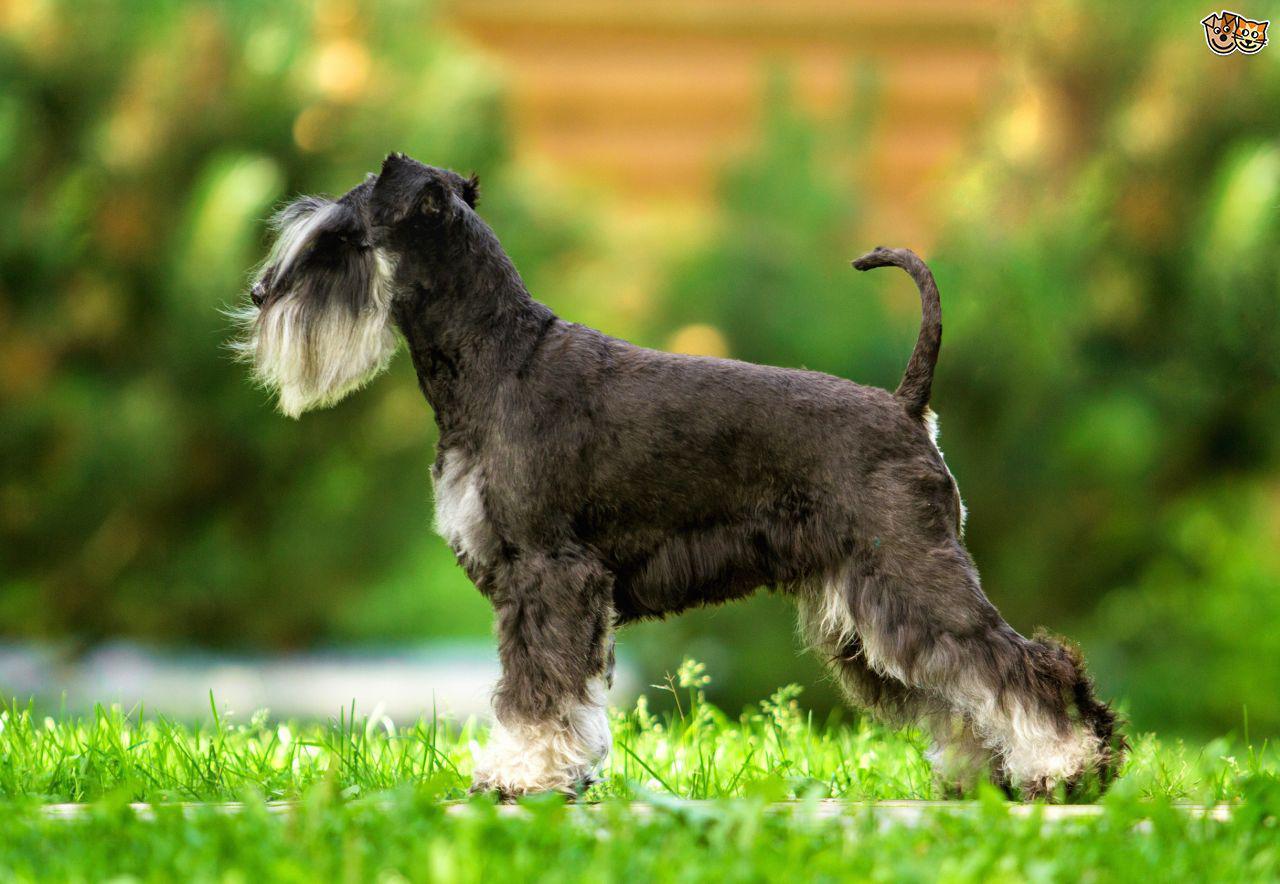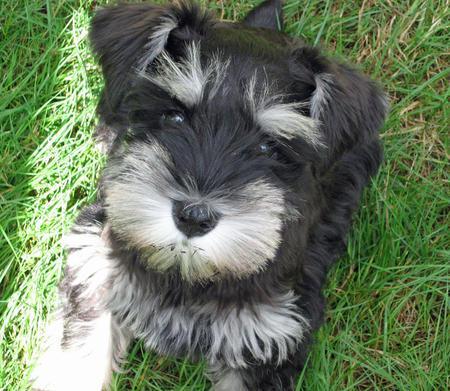The first image is the image on the left, the second image is the image on the right. Considering the images on both sides, is "At least one of the dogs is indoors." valid? Answer yes or no. No. 